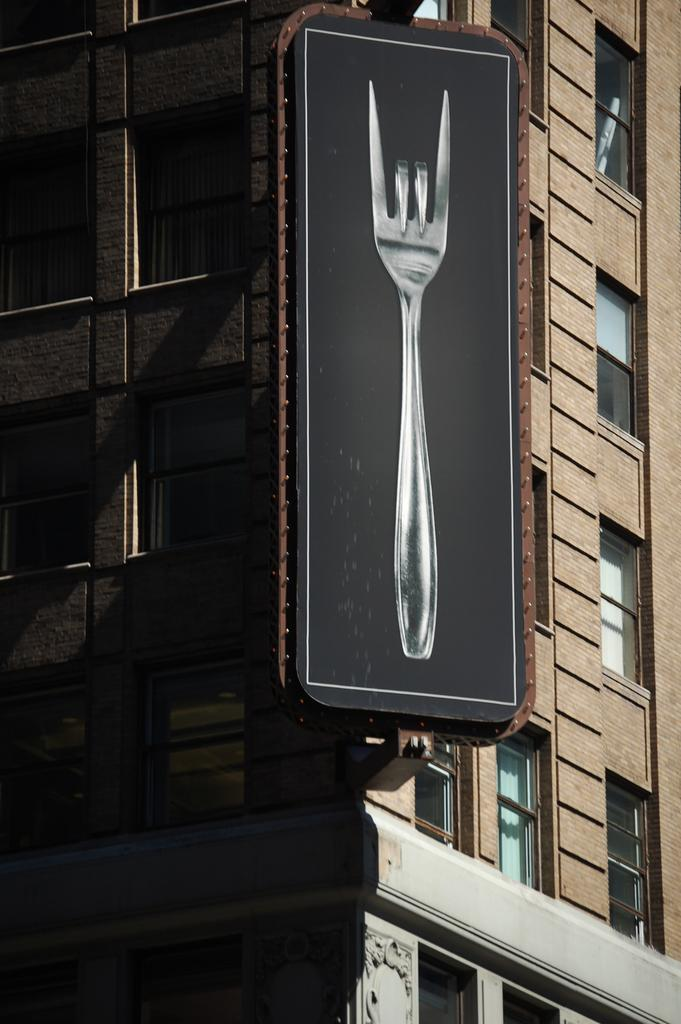What type of structure is visible in the image? There is a building in the image. What is located at the center of the image? There is a hoarding at the center of the image. What song is being played in the background of the image? There is no information about any song being played in the image. 